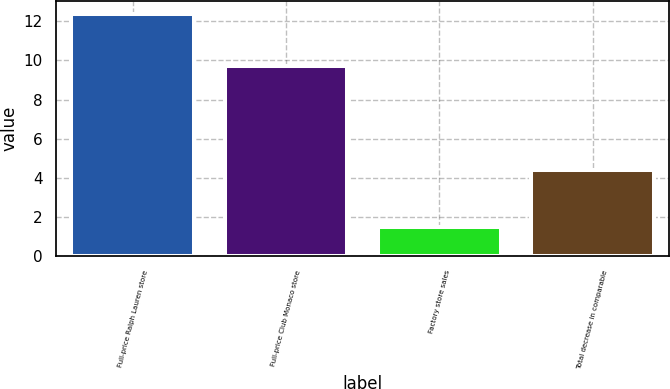Convert chart. <chart><loc_0><loc_0><loc_500><loc_500><bar_chart><fcel>Full-price Ralph Lauren store<fcel>Full-price Club Monaco store<fcel>Factory store sales<fcel>Total decrease in comparable<nl><fcel>12.4<fcel>9.7<fcel>1.5<fcel>4.4<nl></chart> 